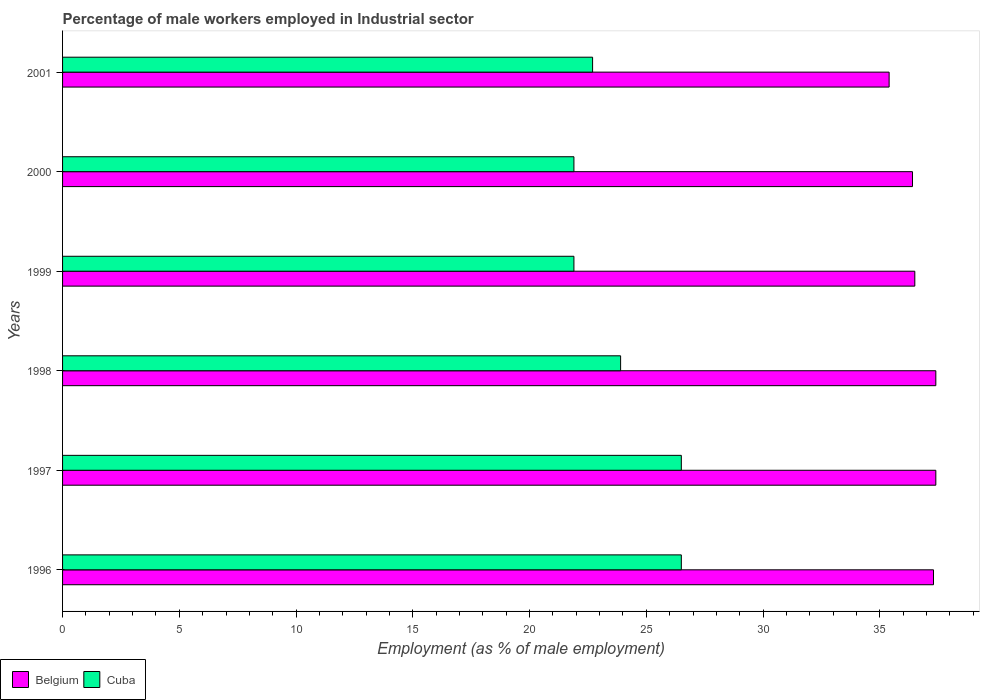How many different coloured bars are there?
Offer a very short reply. 2. Are the number of bars per tick equal to the number of legend labels?
Make the answer very short. Yes. How many bars are there on the 2nd tick from the top?
Keep it short and to the point. 2. In how many cases, is the number of bars for a given year not equal to the number of legend labels?
Provide a short and direct response. 0. Across all years, what is the maximum percentage of male workers employed in Industrial sector in Cuba?
Make the answer very short. 26.5. Across all years, what is the minimum percentage of male workers employed in Industrial sector in Belgium?
Provide a succinct answer. 35.4. In which year was the percentage of male workers employed in Industrial sector in Cuba maximum?
Ensure brevity in your answer.  1996. In which year was the percentage of male workers employed in Industrial sector in Cuba minimum?
Keep it short and to the point. 1999. What is the total percentage of male workers employed in Industrial sector in Cuba in the graph?
Your answer should be compact. 143.4. What is the difference between the percentage of male workers employed in Industrial sector in Belgium in 1996 and the percentage of male workers employed in Industrial sector in Cuba in 2001?
Provide a succinct answer. 14.6. What is the average percentage of male workers employed in Industrial sector in Cuba per year?
Offer a terse response. 23.9. In the year 2001, what is the difference between the percentage of male workers employed in Industrial sector in Belgium and percentage of male workers employed in Industrial sector in Cuba?
Make the answer very short. 12.7. In how many years, is the percentage of male workers employed in Industrial sector in Belgium greater than 17 %?
Offer a terse response. 6. What is the ratio of the percentage of male workers employed in Industrial sector in Belgium in 1998 to that in 2001?
Your response must be concise. 1.06. Is the percentage of male workers employed in Industrial sector in Belgium in 1998 less than that in 2000?
Your answer should be compact. No. Is the difference between the percentage of male workers employed in Industrial sector in Belgium in 1999 and 2000 greater than the difference between the percentage of male workers employed in Industrial sector in Cuba in 1999 and 2000?
Provide a short and direct response. Yes. What is the difference between the highest and the second highest percentage of male workers employed in Industrial sector in Belgium?
Make the answer very short. 0. What is the difference between the highest and the lowest percentage of male workers employed in Industrial sector in Cuba?
Make the answer very short. 4.6. Is the sum of the percentage of male workers employed in Industrial sector in Cuba in 1996 and 2000 greater than the maximum percentage of male workers employed in Industrial sector in Belgium across all years?
Make the answer very short. Yes. What does the 1st bar from the top in 2001 represents?
Provide a succinct answer. Cuba. What does the 2nd bar from the bottom in 1998 represents?
Your answer should be very brief. Cuba. Are all the bars in the graph horizontal?
Your answer should be compact. Yes. What is the title of the graph?
Your answer should be compact. Percentage of male workers employed in Industrial sector. What is the label or title of the X-axis?
Provide a succinct answer. Employment (as % of male employment). What is the Employment (as % of male employment) of Belgium in 1996?
Keep it short and to the point. 37.3. What is the Employment (as % of male employment) in Belgium in 1997?
Provide a short and direct response. 37.4. What is the Employment (as % of male employment) in Belgium in 1998?
Make the answer very short. 37.4. What is the Employment (as % of male employment) of Cuba in 1998?
Ensure brevity in your answer.  23.9. What is the Employment (as % of male employment) of Belgium in 1999?
Provide a short and direct response. 36.5. What is the Employment (as % of male employment) of Cuba in 1999?
Offer a very short reply. 21.9. What is the Employment (as % of male employment) in Belgium in 2000?
Your answer should be compact. 36.4. What is the Employment (as % of male employment) in Cuba in 2000?
Make the answer very short. 21.9. What is the Employment (as % of male employment) in Belgium in 2001?
Ensure brevity in your answer.  35.4. What is the Employment (as % of male employment) in Cuba in 2001?
Make the answer very short. 22.7. Across all years, what is the maximum Employment (as % of male employment) in Belgium?
Provide a short and direct response. 37.4. Across all years, what is the minimum Employment (as % of male employment) of Belgium?
Your answer should be very brief. 35.4. Across all years, what is the minimum Employment (as % of male employment) in Cuba?
Ensure brevity in your answer.  21.9. What is the total Employment (as % of male employment) of Belgium in the graph?
Your answer should be very brief. 220.4. What is the total Employment (as % of male employment) in Cuba in the graph?
Offer a terse response. 143.4. What is the difference between the Employment (as % of male employment) of Belgium in 1996 and that in 1997?
Your answer should be compact. -0.1. What is the difference between the Employment (as % of male employment) of Cuba in 1996 and that in 1998?
Offer a very short reply. 2.6. What is the difference between the Employment (as % of male employment) in Belgium in 1996 and that in 1999?
Keep it short and to the point. 0.8. What is the difference between the Employment (as % of male employment) of Belgium in 1996 and that in 2000?
Make the answer very short. 0.9. What is the difference between the Employment (as % of male employment) in Belgium in 1996 and that in 2001?
Offer a very short reply. 1.9. What is the difference between the Employment (as % of male employment) of Belgium in 1997 and that in 1998?
Offer a terse response. 0. What is the difference between the Employment (as % of male employment) in Cuba in 1997 and that in 1998?
Offer a terse response. 2.6. What is the difference between the Employment (as % of male employment) in Belgium in 1997 and that in 1999?
Give a very brief answer. 0.9. What is the difference between the Employment (as % of male employment) of Cuba in 1997 and that in 2000?
Provide a succinct answer. 4.6. What is the difference between the Employment (as % of male employment) of Cuba in 1997 and that in 2001?
Provide a short and direct response. 3.8. What is the difference between the Employment (as % of male employment) of Belgium in 1998 and that in 2000?
Provide a short and direct response. 1. What is the difference between the Employment (as % of male employment) of Cuba in 1998 and that in 2000?
Offer a very short reply. 2. What is the difference between the Employment (as % of male employment) of Cuba in 1999 and that in 2000?
Offer a very short reply. 0. What is the difference between the Employment (as % of male employment) in Belgium in 1999 and that in 2001?
Your answer should be very brief. 1.1. What is the difference between the Employment (as % of male employment) in Cuba in 1999 and that in 2001?
Keep it short and to the point. -0.8. What is the difference between the Employment (as % of male employment) in Belgium in 2000 and that in 2001?
Give a very brief answer. 1. What is the difference between the Employment (as % of male employment) in Cuba in 2000 and that in 2001?
Keep it short and to the point. -0.8. What is the difference between the Employment (as % of male employment) of Belgium in 1996 and the Employment (as % of male employment) of Cuba in 1998?
Make the answer very short. 13.4. What is the difference between the Employment (as % of male employment) of Belgium in 1996 and the Employment (as % of male employment) of Cuba in 1999?
Provide a succinct answer. 15.4. What is the difference between the Employment (as % of male employment) of Belgium in 1996 and the Employment (as % of male employment) of Cuba in 2000?
Ensure brevity in your answer.  15.4. What is the difference between the Employment (as % of male employment) in Belgium in 1997 and the Employment (as % of male employment) in Cuba in 1998?
Your answer should be compact. 13.5. What is the difference between the Employment (as % of male employment) of Belgium in 1997 and the Employment (as % of male employment) of Cuba in 2001?
Provide a succinct answer. 14.7. What is the difference between the Employment (as % of male employment) in Belgium in 1998 and the Employment (as % of male employment) in Cuba in 2001?
Your answer should be compact. 14.7. What is the difference between the Employment (as % of male employment) in Belgium in 1999 and the Employment (as % of male employment) in Cuba in 2001?
Provide a succinct answer. 13.8. What is the average Employment (as % of male employment) of Belgium per year?
Provide a short and direct response. 36.73. What is the average Employment (as % of male employment) in Cuba per year?
Give a very brief answer. 23.9. In the year 1996, what is the difference between the Employment (as % of male employment) of Belgium and Employment (as % of male employment) of Cuba?
Keep it short and to the point. 10.8. In the year 1997, what is the difference between the Employment (as % of male employment) in Belgium and Employment (as % of male employment) in Cuba?
Ensure brevity in your answer.  10.9. In the year 1998, what is the difference between the Employment (as % of male employment) in Belgium and Employment (as % of male employment) in Cuba?
Give a very brief answer. 13.5. What is the ratio of the Employment (as % of male employment) of Belgium in 1996 to that in 1997?
Your answer should be compact. 1. What is the ratio of the Employment (as % of male employment) of Belgium in 1996 to that in 1998?
Make the answer very short. 1. What is the ratio of the Employment (as % of male employment) of Cuba in 1996 to that in 1998?
Offer a terse response. 1.11. What is the ratio of the Employment (as % of male employment) of Belgium in 1996 to that in 1999?
Offer a very short reply. 1.02. What is the ratio of the Employment (as % of male employment) in Cuba in 1996 to that in 1999?
Offer a very short reply. 1.21. What is the ratio of the Employment (as % of male employment) in Belgium in 1996 to that in 2000?
Provide a short and direct response. 1.02. What is the ratio of the Employment (as % of male employment) of Cuba in 1996 to that in 2000?
Ensure brevity in your answer.  1.21. What is the ratio of the Employment (as % of male employment) of Belgium in 1996 to that in 2001?
Make the answer very short. 1.05. What is the ratio of the Employment (as % of male employment) of Cuba in 1996 to that in 2001?
Provide a succinct answer. 1.17. What is the ratio of the Employment (as % of male employment) in Belgium in 1997 to that in 1998?
Offer a terse response. 1. What is the ratio of the Employment (as % of male employment) of Cuba in 1997 to that in 1998?
Your answer should be compact. 1.11. What is the ratio of the Employment (as % of male employment) of Belgium in 1997 to that in 1999?
Give a very brief answer. 1.02. What is the ratio of the Employment (as % of male employment) of Cuba in 1997 to that in 1999?
Provide a short and direct response. 1.21. What is the ratio of the Employment (as % of male employment) in Belgium in 1997 to that in 2000?
Give a very brief answer. 1.03. What is the ratio of the Employment (as % of male employment) of Cuba in 1997 to that in 2000?
Offer a terse response. 1.21. What is the ratio of the Employment (as % of male employment) in Belgium in 1997 to that in 2001?
Your answer should be very brief. 1.06. What is the ratio of the Employment (as % of male employment) of Cuba in 1997 to that in 2001?
Your answer should be compact. 1.17. What is the ratio of the Employment (as % of male employment) in Belgium in 1998 to that in 1999?
Your answer should be compact. 1.02. What is the ratio of the Employment (as % of male employment) of Cuba in 1998 to that in 1999?
Offer a very short reply. 1.09. What is the ratio of the Employment (as % of male employment) in Belgium in 1998 to that in 2000?
Provide a succinct answer. 1.03. What is the ratio of the Employment (as % of male employment) of Cuba in 1998 to that in 2000?
Offer a very short reply. 1.09. What is the ratio of the Employment (as % of male employment) in Belgium in 1998 to that in 2001?
Ensure brevity in your answer.  1.06. What is the ratio of the Employment (as % of male employment) of Cuba in 1998 to that in 2001?
Your answer should be very brief. 1.05. What is the ratio of the Employment (as % of male employment) of Belgium in 1999 to that in 2001?
Provide a short and direct response. 1.03. What is the ratio of the Employment (as % of male employment) of Cuba in 1999 to that in 2001?
Provide a succinct answer. 0.96. What is the ratio of the Employment (as % of male employment) of Belgium in 2000 to that in 2001?
Your response must be concise. 1.03. What is the ratio of the Employment (as % of male employment) in Cuba in 2000 to that in 2001?
Your response must be concise. 0.96. What is the difference between the highest and the second highest Employment (as % of male employment) of Cuba?
Provide a succinct answer. 0. What is the difference between the highest and the lowest Employment (as % of male employment) in Cuba?
Make the answer very short. 4.6. 